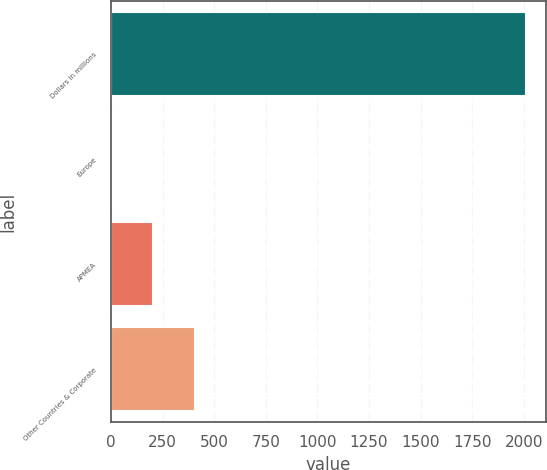<chart> <loc_0><loc_0><loc_500><loc_500><bar_chart><fcel>Dollars in millions<fcel>Europe<fcel>APMEA<fcel>Other Countries & Corporate<nl><fcel>2008<fcel>4<fcel>204.4<fcel>404.8<nl></chart> 